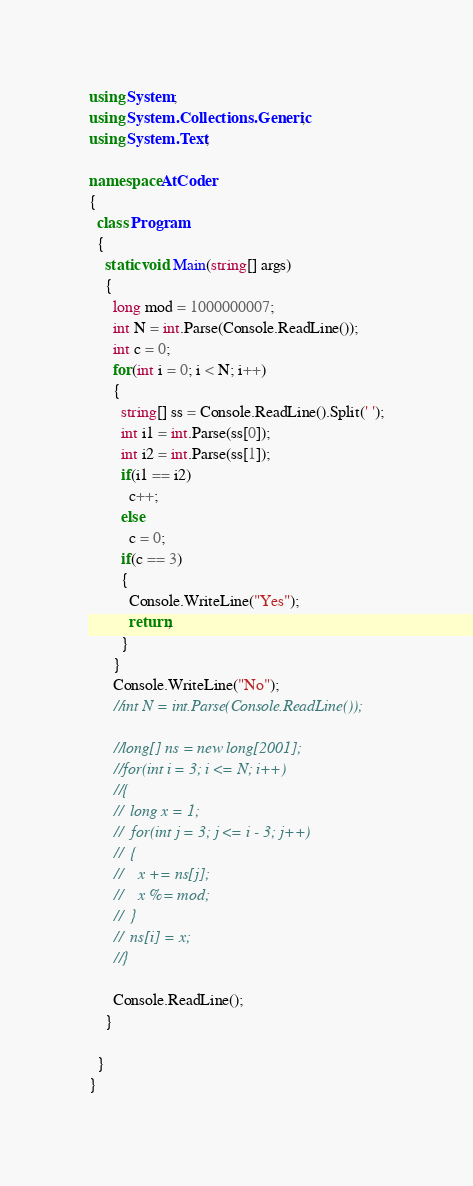Convert code to text. <code><loc_0><loc_0><loc_500><loc_500><_C#_>using System;
using System.Collections.Generic;
using System.Text;

namespace AtCoder
{
  class Program
  {
    static void Main(string[] args)
    {
      long mod = 1000000007;
      int N = int.Parse(Console.ReadLine());
      int c = 0;
      for(int i = 0; i < N; i++)
      {
        string[] ss = Console.ReadLine().Split(' ');
        int i1 = int.Parse(ss[0]);
        int i2 = int.Parse(ss[1]);
        if(i1 == i2)
          c++;
        else
          c = 0;
        if(c == 3)
        {
          Console.WriteLine("Yes");
          return;
        }
      }
      Console.WriteLine("No");
      //int N = int.Parse(Console.ReadLine());

      //long[] ns = new long[2001];
      //for(int i = 3; i <= N; i++)
      //{
      //  long x = 1;
      //  for(int j = 3; j <= i - 3; j++)
      //  {
      //    x += ns[j];
      //    x %= mod;
      //  }
      //  ns[i] = x;
      //}

      Console.ReadLine();
    }
    
  }
}</code> 